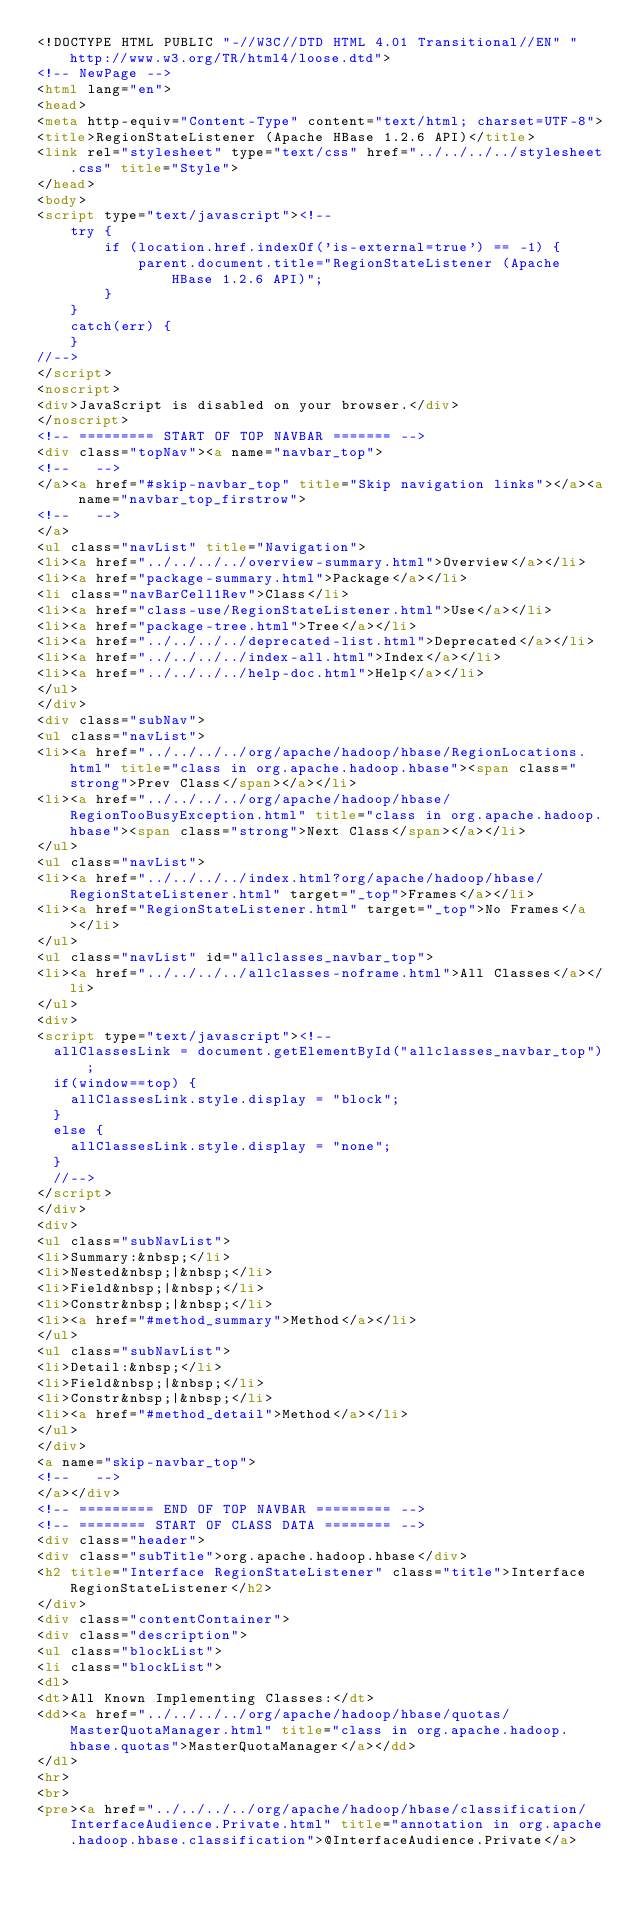Convert code to text. <code><loc_0><loc_0><loc_500><loc_500><_HTML_><!DOCTYPE HTML PUBLIC "-//W3C//DTD HTML 4.01 Transitional//EN" "http://www.w3.org/TR/html4/loose.dtd">
<!-- NewPage -->
<html lang="en">
<head>
<meta http-equiv="Content-Type" content="text/html; charset=UTF-8">
<title>RegionStateListener (Apache HBase 1.2.6 API)</title>
<link rel="stylesheet" type="text/css" href="../../../../stylesheet.css" title="Style">
</head>
<body>
<script type="text/javascript"><!--
    try {
        if (location.href.indexOf('is-external=true') == -1) {
            parent.document.title="RegionStateListener (Apache HBase 1.2.6 API)";
        }
    }
    catch(err) {
    }
//-->
</script>
<noscript>
<div>JavaScript is disabled on your browser.</div>
</noscript>
<!-- ========= START OF TOP NAVBAR ======= -->
<div class="topNav"><a name="navbar_top">
<!--   -->
</a><a href="#skip-navbar_top" title="Skip navigation links"></a><a name="navbar_top_firstrow">
<!--   -->
</a>
<ul class="navList" title="Navigation">
<li><a href="../../../../overview-summary.html">Overview</a></li>
<li><a href="package-summary.html">Package</a></li>
<li class="navBarCell1Rev">Class</li>
<li><a href="class-use/RegionStateListener.html">Use</a></li>
<li><a href="package-tree.html">Tree</a></li>
<li><a href="../../../../deprecated-list.html">Deprecated</a></li>
<li><a href="../../../../index-all.html">Index</a></li>
<li><a href="../../../../help-doc.html">Help</a></li>
</ul>
</div>
<div class="subNav">
<ul class="navList">
<li><a href="../../../../org/apache/hadoop/hbase/RegionLocations.html" title="class in org.apache.hadoop.hbase"><span class="strong">Prev Class</span></a></li>
<li><a href="../../../../org/apache/hadoop/hbase/RegionTooBusyException.html" title="class in org.apache.hadoop.hbase"><span class="strong">Next Class</span></a></li>
</ul>
<ul class="navList">
<li><a href="../../../../index.html?org/apache/hadoop/hbase/RegionStateListener.html" target="_top">Frames</a></li>
<li><a href="RegionStateListener.html" target="_top">No Frames</a></li>
</ul>
<ul class="navList" id="allclasses_navbar_top">
<li><a href="../../../../allclasses-noframe.html">All Classes</a></li>
</ul>
<div>
<script type="text/javascript"><!--
  allClassesLink = document.getElementById("allclasses_navbar_top");
  if(window==top) {
    allClassesLink.style.display = "block";
  }
  else {
    allClassesLink.style.display = "none";
  }
  //-->
</script>
</div>
<div>
<ul class="subNavList">
<li>Summary:&nbsp;</li>
<li>Nested&nbsp;|&nbsp;</li>
<li>Field&nbsp;|&nbsp;</li>
<li>Constr&nbsp;|&nbsp;</li>
<li><a href="#method_summary">Method</a></li>
</ul>
<ul class="subNavList">
<li>Detail:&nbsp;</li>
<li>Field&nbsp;|&nbsp;</li>
<li>Constr&nbsp;|&nbsp;</li>
<li><a href="#method_detail">Method</a></li>
</ul>
</div>
<a name="skip-navbar_top">
<!--   -->
</a></div>
<!-- ========= END OF TOP NAVBAR ========= -->
<!-- ======== START OF CLASS DATA ======== -->
<div class="header">
<div class="subTitle">org.apache.hadoop.hbase</div>
<h2 title="Interface RegionStateListener" class="title">Interface RegionStateListener</h2>
</div>
<div class="contentContainer">
<div class="description">
<ul class="blockList">
<li class="blockList">
<dl>
<dt>All Known Implementing Classes:</dt>
<dd><a href="../../../../org/apache/hadoop/hbase/quotas/MasterQuotaManager.html" title="class in org.apache.hadoop.hbase.quotas">MasterQuotaManager</a></dd>
</dl>
<hr>
<br>
<pre><a href="../../../../org/apache/hadoop/hbase/classification/InterfaceAudience.Private.html" title="annotation in org.apache.hadoop.hbase.classification">@InterfaceAudience.Private</a></code> 